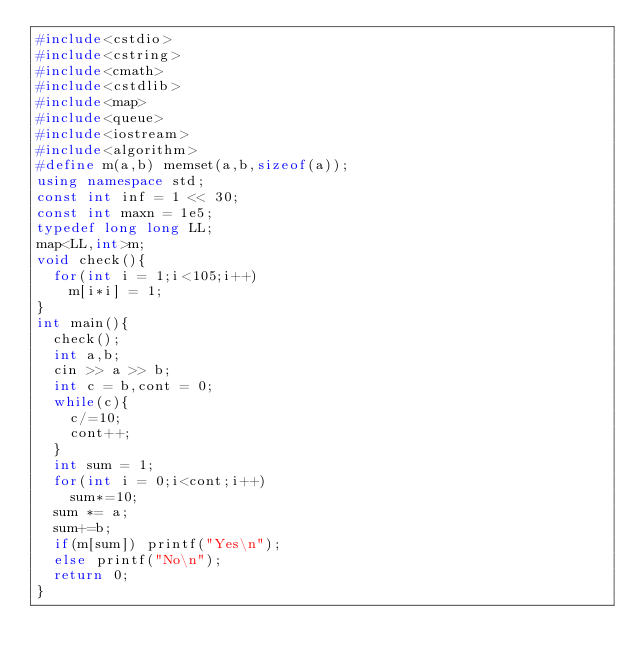Convert code to text. <code><loc_0><loc_0><loc_500><loc_500><_C++_>#include<cstdio>
#include<cstring>
#include<cmath>
#include<cstdlib>
#include<map>
#include<queue>
#include<iostream>
#include<algorithm>
#define m(a,b) memset(a,b,sizeof(a));
using namespace std;
const int inf = 1 << 30;
const int maxn = 1e5;
typedef long long LL;
map<LL,int>m;
void check(){
	for(int i = 1;i<105;i++)
		m[i*i] = 1;
}
int main(){
	check();
	int a,b;
	cin >> a >> b;
	int c = b,cont = 0;
	while(c){
		c/=10;
		cont++;
	}
	int sum = 1;
	for(int i = 0;i<cont;i++)
		sum*=10;
	sum *= a;
	sum+=b;
	if(m[sum]) printf("Yes\n");
	else printf("No\n");
	return 0;
}</code> 